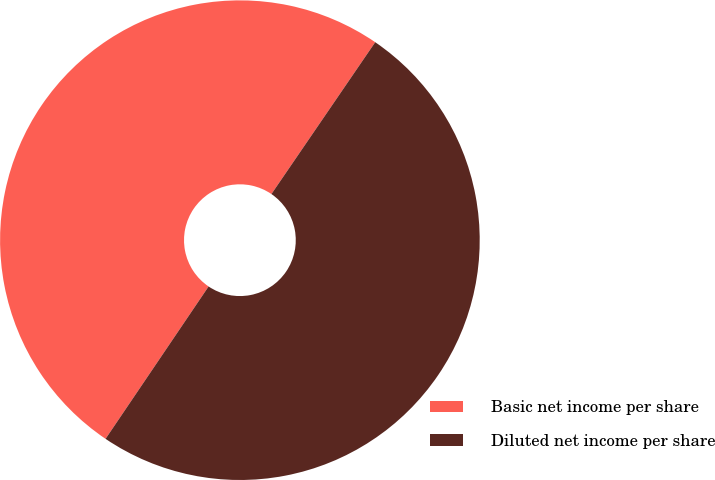Convert chart. <chart><loc_0><loc_0><loc_500><loc_500><pie_chart><fcel>Basic net income per share<fcel>Diluted net income per share<nl><fcel>50.08%<fcel>49.92%<nl></chart> 